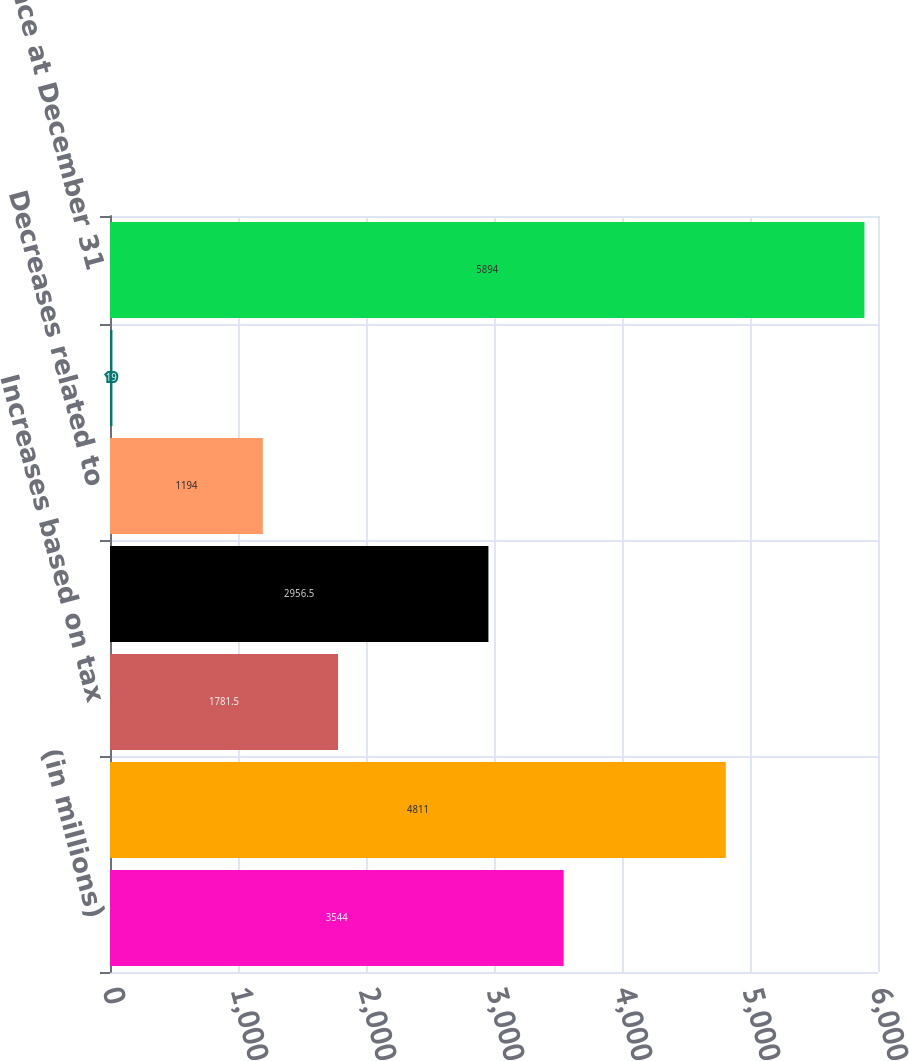<chart> <loc_0><loc_0><loc_500><loc_500><bar_chart><fcel>(in millions)<fcel>Balance at January 1<fcel>Increases based on tax<fcel>Decreases based on tax<fcel>Decreases related to<fcel>Decreases related to a lapse<fcel>Balance at December 31<nl><fcel>3544<fcel>4811<fcel>1781.5<fcel>2956.5<fcel>1194<fcel>19<fcel>5894<nl></chart> 